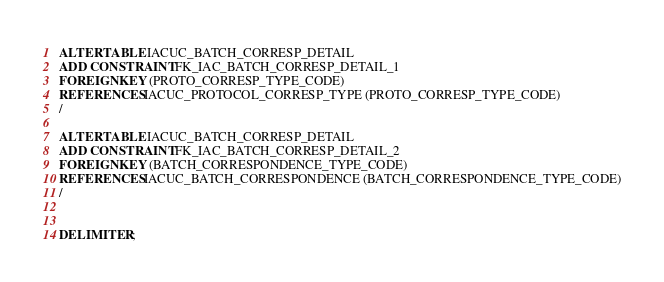Convert code to text. <code><loc_0><loc_0><loc_500><loc_500><_SQL_>ALTER TABLE IACUC_BATCH_CORRESP_DETAIL 
ADD CONSTRAINT FK_IAC_BATCH_CORRESP_DETAIL_1 
FOREIGN KEY (PROTO_CORRESP_TYPE_CODE) 
REFERENCES IACUC_PROTOCOL_CORRESP_TYPE (PROTO_CORRESP_TYPE_CODE)
/

ALTER TABLE IACUC_BATCH_CORRESP_DETAIL 
ADD CONSTRAINT FK_IAC_BATCH_CORRESP_DETAIL_2 
FOREIGN KEY (BATCH_CORRESPONDENCE_TYPE_CODE) 
REFERENCES IACUC_BATCH_CORRESPONDENCE (BATCH_CORRESPONDENCE_TYPE_CODE)
/


DELIMITER ;
</code> 